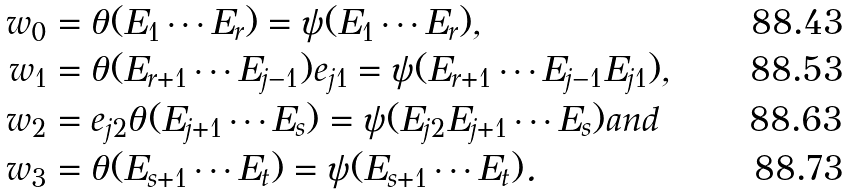Convert formula to latex. <formula><loc_0><loc_0><loc_500><loc_500>w _ { 0 } & = \theta ( E _ { 1 } \cdots E _ { r } ) = \psi ( E _ { 1 } \cdots E _ { r } ) , \\ w _ { 1 } & = \theta ( E _ { r + 1 } \cdots E _ { j - 1 } ) e _ { j 1 } = \psi ( E _ { r + 1 } \cdots E _ { j - 1 } E _ { j 1 } ) , \\ w _ { 2 } & = e _ { j 2 } \theta ( E _ { j + 1 } \cdots E _ { s } ) = \psi ( E _ { j 2 } E _ { j + 1 } \cdots E _ { s } ) a n d \\ w _ { 3 } & = \theta ( E _ { s + 1 } \cdots E _ { t } ) = \psi ( E _ { s + 1 } \cdots E _ { t } ) .</formula> 